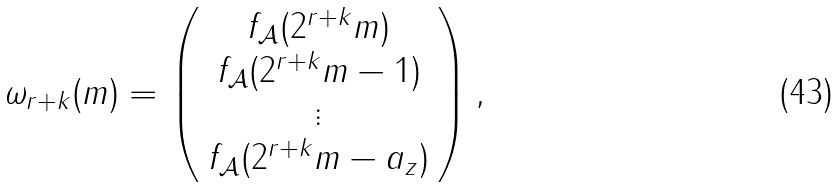Convert formula to latex. <formula><loc_0><loc_0><loc_500><loc_500>\omega _ { r + k } ( m ) = \left ( \begin{array} { c } f _ { \mathcal { A } } ( 2 ^ { r + k } m ) \\ f _ { \mathcal { A } } ( 2 ^ { r + k } m - 1 ) \\ \vdots \\ f _ { \mathcal { A } } ( 2 ^ { r + k } m - a _ { z } ) \\ \end{array} \right ) ,</formula> 